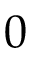Convert formula to latex. <formula><loc_0><loc_0><loc_500><loc_500>0</formula> 